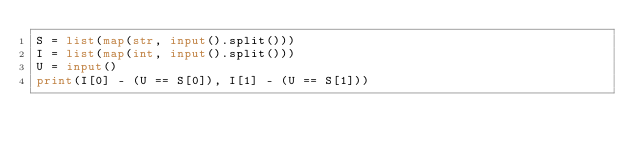Convert code to text. <code><loc_0><loc_0><loc_500><loc_500><_Python_>S = list(map(str, input().split()))
I = list(map(int, input().split()))
U = input()
print(I[0] - (U == S[0]), I[1] - (U == S[1]))</code> 